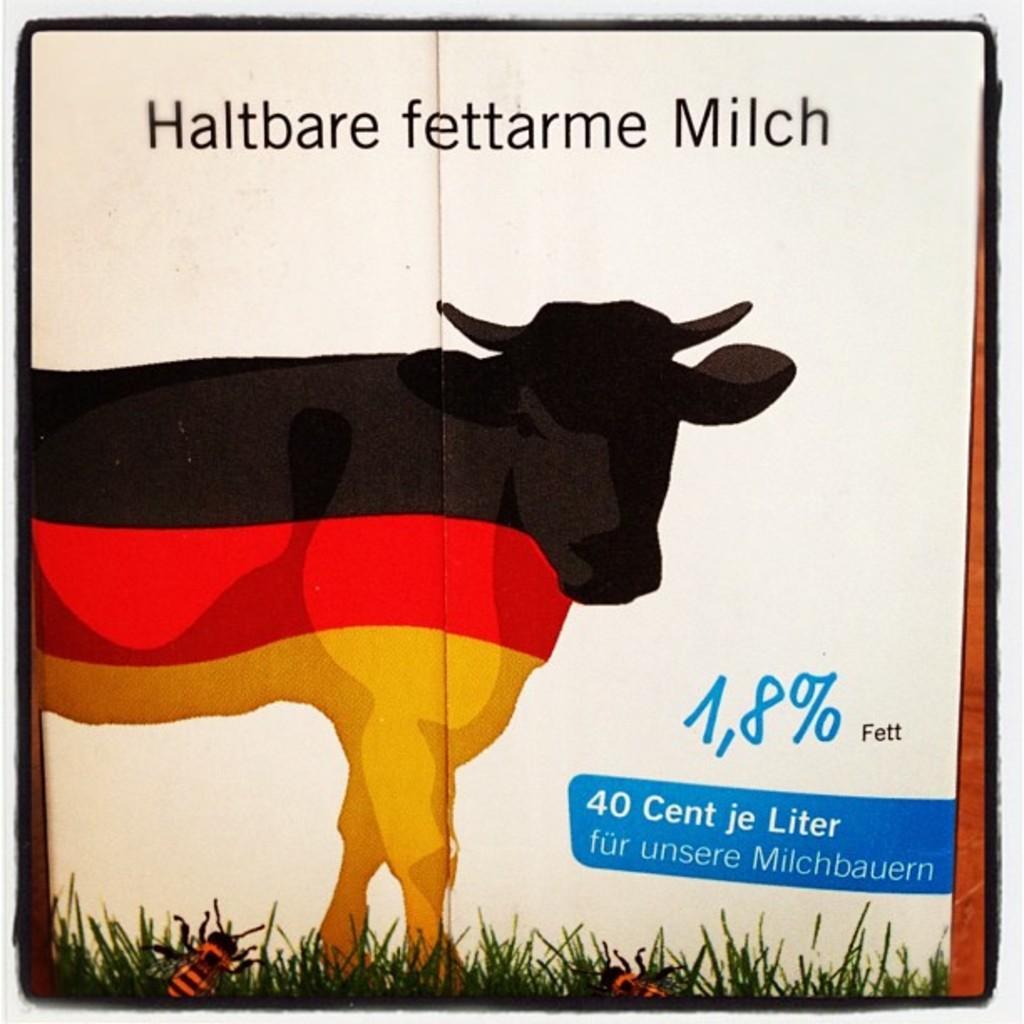Describe this image in one or two sentences. As we can see in the image there is a poster. On poster there is a cow, grass and insects. 